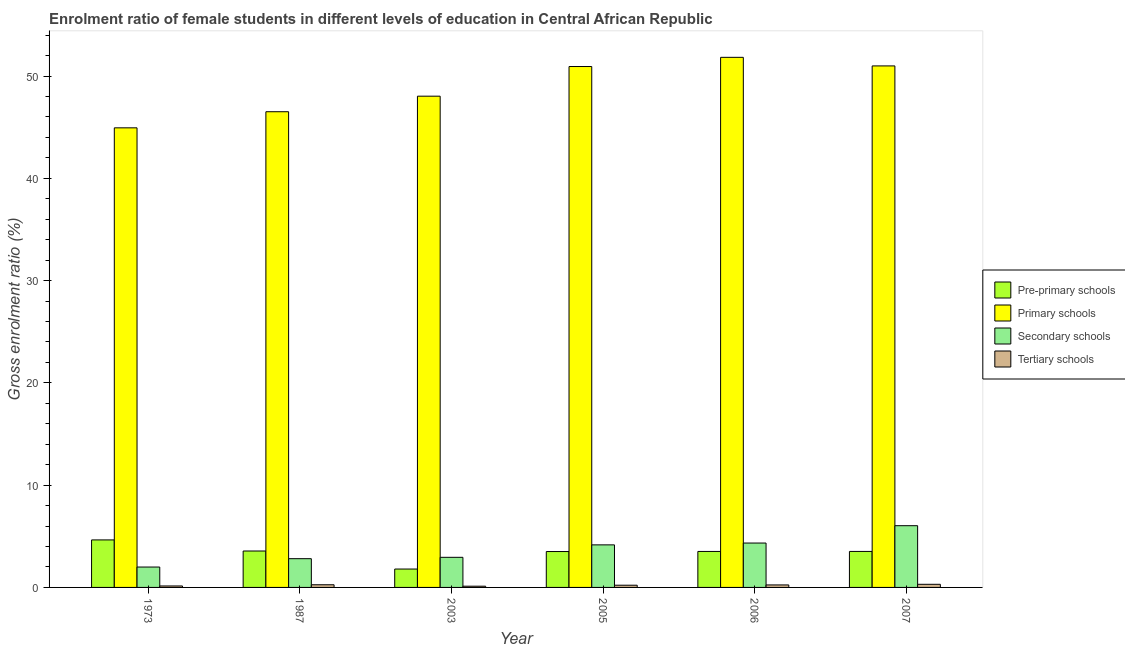How many bars are there on the 3rd tick from the right?
Your answer should be compact. 4. What is the label of the 2nd group of bars from the left?
Give a very brief answer. 1987. What is the gross enrolment ratio(male) in tertiary schools in 2007?
Provide a short and direct response. 0.31. Across all years, what is the maximum gross enrolment ratio(male) in tertiary schools?
Offer a terse response. 0.31. Across all years, what is the minimum gross enrolment ratio(male) in tertiary schools?
Offer a terse response. 0.12. What is the total gross enrolment ratio(male) in pre-primary schools in the graph?
Provide a succinct answer. 20.55. What is the difference between the gross enrolment ratio(male) in tertiary schools in 1973 and that in 2006?
Your answer should be very brief. -0.1. What is the difference between the gross enrolment ratio(male) in tertiary schools in 2007 and the gross enrolment ratio(male) in secondary schools in 1973?
Offer a terse response. 0.16. What is the average gross enrolment ratio(male) in primary schools per year?
Offer a terse response. 48.88. In the year 2007, what is the difference between the gross enrolment ratio(male) in secondary schools and gross enrolment ratio(male) in primary schools?
Your response must be concise. 0. What is the ratio of the gross enrolment ratio(male) in primary schools in 1973 to that in 2003?
Your answer should be compact. 0.94. What is the difference between the highest and the second highest gross enrolment ratio(male) in pre-primary schools?
Your response must be concise. 1.08. What is the difference between the highest and the lowest gross enrolment ratio(male) in secondary schools?
Make the answer very short. 4.04. In how many years, is the gross enrolment ratio(male) in primary schools greater than the average gross enrolment ratio(male) in primary schools taken over all years?
Ensure brevity in your answer.  3. Is the sum of the gross enrolment ratio(male) in secondary schools in 1987 and 2006 greater than the maximum gross enrolment ratio(male) in pre-primary schools across all years?
Ensure brevity in your answer.  Yes. Is it the case that in every year, the sum of the gross enrolment ratio(male) in pre-primary schools and gross enrolment ratio(male) in secondary schools is greater than the sum of gross enrolment ratio(male) in primary schools and gross enrolment ratio(male) in tertiary schools?
Offer a terse response. Yes. What does the 1st bar from the left in 1987 represents?
Your response must be concise. Pre-primary schools. What does the 1st bar from the right in 2007 represents?
Provide a short and direct response. Tertiary schools. Is it the case that in every year, the sum of the gross enrolment ratio(male) in pre-primary schools and gross enrolment ratio(male) in primary schools is greater than the gross enrolment ratio(male) in secondary schools?
Your response must be concise. Yes. Are all the bars in the graph horizontal?
Offer a very short reply. No. How many years are there in the graph?
Your response must be concise. 6. Does the graph contain any zero values?
Offer a very short reply. No. Does the graph contain grids?
Keep it short and to the point. No. Where does the legend appear in the graph?
Your response must be concise. Center right. How many legend labels are there?
Offer a very short reply. 4. What is the title of the graph?
Give a very brief answer. Enrolment ratio of female students in different levels of education in Central African Republic. What is the Gross enrolment ratio (%) of Pre-primary schools in 1973?
Offer a very short reply. 4.65. What is the Gross enrolment ratio (%) of Primary schools in 1973?
Your response must be concise. 44.94. What is the Gross enrolment ratio (%) of Secondary schools in 1973?
Make the answer very short. 1.99. What is the Gross enrolment ratio (%) in Tertiary schools in 1973?
Your response must be concise. 0.14. What is the Gross enrolment ratio (%) of Pre-primary schools in 1987?
Your answer should be compact. 3.56. What is the Gross enrolment ratio (%) in Primary schools in 1987?
Offer a very short reply. 46.51. What is the Gross enrolment ratio (%) in Secondary schools in 1987?
Your answer should be compact. 2.81. What is the Gross enrolment ratio (%) in Tertiary schools in 1987?
Make the answer very short. 0.26. What is the Gross enrolment ratio (%) of Pre-primary schools in 2003?
Provide a short and direct response. 1.8. What is the Gross enrolment ratio (%) in Primary schools in 2003?
Provide a short and direct response. 48.03. What is the Gross enrolment ratio (%) of Secondary schools in 2003?
Your response must be concise. 2.94. What is the Gross enrolment ratio (%) of Tertiary schools in 2003?
Give a very brief answer. 0.12. What is the Gross enrolment ratio (%) in Pre-primary schools in 2005?
Keep it short and to the point. 3.51. What is the Gross enrolment ratio (%) in Primary schools in 2005?
Provide a short and direct response. 50.94. What is the Gross enrolment ratio (%) in Secondary schools in 2005?
Give a very brief answer. 4.16. What is the Gross enrolment ratio (%) of Tertiary schools in 2005?
Your answer should be compact. 0.22. What is the Gross enrolment ratio (%) in Pre-primary schools in 2006?
Your answer should be compact. 3.52. What is the Gross enrolment ratio (%) in Primary schools in 2006?
Your response must be concise. 51.83. What is the Gross enrolment ratio (%) in Secondary schools in 2006?
Your response must be concise. 4.34. What is the Gross enrolment ratio (%) in Tertiary schools in 2006?
Your answer should be compact. 0.24. What is the Gross enrolment ratio (%) in Pre-primary schools in 2007?
Offer a very short reply. 3.52. What is the Gross enrolment ratio (%) of Primary schools in 2007?
Ensure brevity in your answer.  50.99. What is the Gross enrolment ratio (%) of Secondary schools in 2007?
Ensure brevity in your answer.  6.04. What is the Gross enrolment ratio (%) in Tertiary schools in 2007?
Offer a terse response. 0.31. Across all years, what is the maximum Gross enrolment ratio (%) in Pre-primary schools?
Give a very brief answer. 4.65. Across all years, what is the maximum Gross enrolment ratio (%) of Primary schools?
Ensure brevity in your answer.  51.83. Across all years, what is the maximum Gross enrolment ratio (%) in Secondary schools?
Provide a succinct answer. 6.04. Across all years, what is the maximum Gross enrolment ratio (%) in Tertiary schools?
Your response must be concise. 0.31. Across all years, what is the minimum Gross enrolment ratio (%) of Pre-primary schools?
Your answer should be very brief. 1.8. Across all years, what is the minimum Gross enrolment ratio (%) in Primary schools?
Your answer should be compact. 44.94. Across all years, what is the minimum Gross enrolment ratio (%) in Secondary schools?
Make the answer very short. 1.99. Across all years, what is the minimum Gross enrolment ratio (%) in Tertiary schools?
Your answer should be very brief. 0.12. What is the total Gross enrolment ratio (%) of Pre-primary schools in the graph?
Your answer should be compact. 20.55. What is the total Gross enrolment ratio (%) in Primary schools in the graph?
Give a very brief answer. 293.25. What is the total Gross enrolment ratio (%) of Secondary schools in the graph?
Give a very brief answer. 22.29. What is the total Gross enrolment ratio (%) in Tertiary schools in the graph?
Give a very brief answer. 1.29. What is the difference between the Gross enrolment ratio (%) of Pre-primary schools in 1973 and that in 1987?
Provide a succinct answer. 1.08. What is the difference between the Gross enrolment ratio (%) in Primary schools in 1973 and that in 1987?
Keep it short and to the point. -1.57. What is the difference between the Gross enrolment ratio (%) of Secondary schools in 1973 and that in 1987?
Your answer should be very brief. -0.82. What is the difference between the Gross enrolment ratio (%) of Tertiary schools in 1973 and that in 1987?
Make the answer very short. -0.12. What is the difference between the Gross enrolment ratio (%) in Pre-primary schools in 1973 and that in 2003?
Your answer should be very brief. 2.85. What is the difference between the Gross enrolment ratio (%) of Primary schools in 1973 and that in 2003?
Your answer should be compact. -3.09. What is the difference between the Gross enrolment ratio (%) of Secondary schools in 1973 and that in 2003?
Offer a very short reply. -0.95. What is the difference between the Gross enrolment ratio (%) in Tertiary schools in 1973 and that in 2003?
Offer a very short reply. 0.02. What is the difference between the Gross enrolment ratio (%) of Pre-primary schools in 1973 and that in 2005?
Your answer should be very brief. 1.14. What is the difference between the Gross enrolment ratio (%) of Primary schools in 1973 and that in 2005?
Ensure brevity in your answer.  -6. What is the difference between the Gross enrolment ratio (%) of Secondary schools in 1973 and that in 2005?
Your answer should be very brief. -2.17. What is the difference between the Gross enrolment ratio (%) in Tertiary schools in 1973 and that in 2005?
Make the answer very short. -0.07. What is the difference between the Gross enrolment ratio (%) in Pre-primary schools in 1973 and that in 2006?
Your response must be concise. 1.13. What is the difference between the Gross enrolment ratio (%) of Primary schools in 1973 and that in 2006?
Keep it short and to the point. -6.89. What is the difference between the Gross enrolment ratio (%) of Secondary schools in 1973 and that in 2006?
Your answer should be compact. -2.35. What is the difference between the Gross enrolment ratio (%) in Tertiary schools in 1973 and that in 2006?
Your answer should be compact. -0.1. What is the difference between the Gross enrolment ratio (%) in Pre-primary schools in 1973 and that in 2007?
Keep it short and to the point. 1.13. What is the difference between the Gross enrolment ratio (%) in Primary schools in 1973 and that in 2007?
Make the answer very short. -6.05. What is the difference between the Gross enrolment ratio (%) of Secondary schools in 1973 and that in 2007?
Provide a short and direct response. -4.04. What is the difference between the Gross enrolment ratio (%) of Tertiary schools in 1973 and that in 2007?
Make the answer very short. -0.16. What is the difference between the Gross enrolment ratio (%) in Pre-primary schools in 1987 and that in 2003?
Provide a succinct answer. 1.76. What is the difference between the Gross enrolment ratio (%) of Primary schools in 1987 and that in 2003?
Give a very brief answer. -1.52. What is the difference between the Gross enrolment ratio (%) of Secondary schools in 1987 and that in 2003?
Your response must be concise. -0.13. What is the difference between the Gross enrolment ratio (%) in Tertiary schools in 1987 and that in 2003?
Keep it short and to the point. 0.14. What is the difference between the Gross enrolment ratio (%) in Pre-primary schools in 1987 and that in 2005?
Give a very brief answer. 0.05. What is the difference between the Gross enrolment ratio (%) in Primary schools in 1987 and that in 2005?
Your answer should be compact. -4.42. What is the difference between the Gross enrolment ratio (%) in Secondary schools in 1987 and that in 2005?
Your answer should be compact. -1.35. What is the difference between the Gross enrolment ratio (%) of Tertiary schools in 1987 and that in 2005?
Offer a terse response. 0.04. What is the difference between the Gross enrolment ratio (%) of Pre-primary schools in 1987 and that in 2006?
Provide a short and direct response. 0.04. What is the difference between the Gross enrolment ratio (%) of Primary schools in 1987 and that in 2006?
Offer a very short reply. -5.32. What is the difference between the Gross enrolment ratio (%) of Secondary schools in 1987 and that in 2006?
Keep it short and to the point. -1.53. What is the difference between the Gross enrolment ratio (%) in Tertiary schools in 1987 and that in 2006?
Provide a succinct answer. 0.02. What is the difference between the Gross enrolment ratio (%) of Pre-primary schools in 1987 and that in 2007?
Ensure brevity in your answer.  0.04. What is the difference between the Gross enrolment ratio (%) in Primary schools in 1987 and that in 2007?
Provide a succinct answer. -4.48. What is the difference between the Gross enrolment ratio (%) in Secondary schools in 1987 and that in 2007?
Keep it short and to the point. -3.22. What is the difference between the Gross enrolment ratio (%) in Tertiary schools in 1987 and that in 2007?
Provide a short and direct response. -0.04. What is the difference between the Gross enrolment ratio (%) in Pre-primary schools in 2003 and that in 2005?
Your answer should be compact. -1.71. What is the difference between the Gross enrolment ratio (%) of Primary schools in 2003 and that in 2005?
Provide a short and direct response. -2.9. What is the difference between the Gross enrolment ratio (%) of Secondary schools in 2003 and that in 2005?
Offer a very short reply. -1.22. What is the difference between the Gross enrolment ratio (%) in Tertiary schools in 2003 and that in 2005?
Your response must be concise. -0.1. What is the difference between the Gross enrolment ratio (%) in Pre-primary schools in 2003 and that in 2006?
Make the answer very short. -1.72. What is the difference between the Gross enrolment ratio (%) in Primary schools in 2003 and that in 2006?
Your answer should be very brief. -3.8. What is the difference between the Gross enrolment ratio (%) of Secondary schools in 2003 and that in 2006?
Provide a succinct answer. -1.4. What is the difference between the Gross enrolment ratio (%) of Tertiary schools in 2003 and that in 2006?
Your response must be concise. -0.12. What is the difference between the Gross enrolment ratio (%) in Pre-primary schools in 2003 and that in 2007?
Your answer should be compact. -1.72. What is the difference between the Gross enrolment ratio (%) of Primary schools in 2003 and that in 2007?
Keep it short and to the point. -2.96. What is the difference between the Gross enrolment ratio (%) in Secondary schools in 2003 and that in 2007?
Make the answer very short. -3.09. What is the difference between the Gross enrolment ratio (%) in Tertiary schools in 2003 and that in 2007?
Offer a very short reply. -0.19. What is the difference between the Gross enrolment ratio (%) in Pre-primary schools in 2005 and that in 2006?
Offer a terse response. -0.01. What is the difference between the Gross enrolment ratio (%) in Primary schools in 2005 and that in 2006?
Keep it short and to the point. -0.9. What is the difference between the Gross enrolment ratio (%) of Secondary schools in 2005 and that in 2006?
Give a very brief answer. -0.18. What is the difference between the Gross enrolment ratio (%) in Tertiary schools in 2005 and that in 2006?
Make the answer very short. -0.03. What is the difference between the Gross enrolment ratio (%) of Pre-primary schools in 2005 and that in 2007?
Your answer should be compact. -0.01. What is the difference between the Gross enrolment ratio (%) in Primary schools in 2005 and that in 2007?
Make the answer very short. -0.06. What is the difference between the Gross enrolment ratio (%) of Secondary schools in 2005 and that in 2007?
Your answer should be very brief. -1.87. What is the difference between the Gross enrolment ratio (%) of Tertiary schools in 2005 and that in 2007?
Provide a short and direct response. -0.09. What is the difference between the Gross enrolment ratio (%) in Pre-primary schools in 2006 and that in 2007?
Make the answer very short. -0. What is the difference between the Gross enrolment ratio (%) in Primary schools in 2006 and that in 2007?
Make the answer very short. 0.84. What is the difference between the Gross enrolment ratio (%) in Secondary schools in 2006 and that in 2007?
Give a very brief answer. -1.69. What is the difference between the Gross enrolment ratio (%) in Tertiary schools in 2006 and that in 2007?
Ensure brevity in your answer.  -0.06. What is the difference between the Gross enrolment ratio (%) of Pre-primary schools in 1973 and the Gross enrolment ratio (%) of Primary schools in 1987?
Keep it short and to the point. -41.87. What is the difference between the Gross enrolment ratio (%) in Pre-primary schools in 1973 and the Gross enrolment ratio (%) in Secondary schools in 1987?
Your response must be concise. 1.83. What is the difference between the Gross enrolment ratio (%) in Pre-primary schools in 1973 and the Gross enrolment ratio (%) in Tertiary schools in 1987?
Keep it short and to the point. 4.38. What is the difference between the Gross enrolment ratio (%) in Primary schools in 1973 and the Gross enrolment ratio (%) in Secondary schools in 1987?
Give a very brief answer. 42.13. What is the difference between the Gross enrolment ratio (%) of Primary schools in 1973 and the Gross enrolment ratio (%) of Tertiary schools in 1987?
Ensure brevity in your answer.  44.68. What is the difference between the Gross enrolment ratio (%) in Secondary schools in 1973 and the Gross enrolment ratio (%) in Tertiary schools in 1987?
Provide a succinct answer. 1.73. What is the difference between the Gross enrolment ratio (%) in Pre-primary schools in 1973 and the Gross enrolment ratio (%) in Primary schools in 2003?
Your answer should be very brief. -43.39. What is the difference between the Gross enrolment ratio (%) of Pre-primary schools in 1973 and the Gross enrolment ratio (%) of Secondary schools in 2003?
Keep it short and to the point. 1.7. What is the difference between the Gross enrolment ratio (%) of Pre-primary schools in 1973 and the Gross enrolment ratio (%) of Tertiary schools in 2003?
Offer a very short reply. 4.53. What is the difference between the Gross enrolment ratio (%) of Primary schools in 1973 and the Gross enrolment ratio (%) of Secondary schools in 2003?
Keep it short and to the point. 42. What is the difference between the Gross enrolment ratio (%) of Primary schools in 1973 and the Gross enrolment ratio (%) of Tertiary schools in 2003?
Ensure brevity in your answer.  44.82. What is the difference between the Gross enrolment ratio (%) of Secondary schools in 1973 and the Gross enrolment ratio (%) of Tertiary schools in 2003?
Your response must be concise. 1.87. What is the difference between the Gross enrolment ratio (%) in Pre-primary schools in 1973 and the Gross enrolment ratio (%) in Primary schools in 2005?
Your response must be concise. -46.29. What is the difference between the Gross enrolment ratio (%) in Pre-primary schools in 1973 and the Gross enrolment ratio (%) in Secondary schools in 2005?
Give a very brief answer. 0.48. What is the difference between the Gross enrolment ratio (%) of Pre-primary schools in 1973 and the Gross enrolment ratio (%) of Tertiary schools in 2005?
Offer a terse response. 4.43. What is the difference between the Gross enrolment ratio (%) of Primary schools in 1973 and the Gross enrolment ratio (%) of Secondary schools in 2005?
Make the answer very short. 40.78. What is the difference between the Gross enrolment ratio (%) of Primary schools in 1973 and the Gross enrolment ratio (%) of Tertiary schools in 2005?
Make the answer very short. 44.72. What is the difference between the Gross enrolment ratio (%) of Secondary schools in 1973 and the Gross enrolment ratio (%) of Tertiary schools in 2005?
Give a very brief answer. 1.78. What is the difference between the Gross enrolment ratio (%) of Pre-primary schools in 1973 and the Gross enrolment ratio (%) of Primary schools in 2006?
Provide a short and direct response. -47.19. What is the difference between the Gross enrolment ratio (%) of Pre-primary schools in 1973 and the Gross enrolment ratio (%) of Secondary schools in 2006?
Provide a succinct answer. 0.31. What is the difference between the Gross enrolment ratio (%) in Pre-primary schools in 1973 and the Gross enrolment ratio (%) in Tertiary schools in 2006?
Your answer should be very brief. 4.4. What is the difference between the Gross enrolment ratio (%) in Primary schools in 1973 and the Gross enrolment ratio (%) in Secondary schools in 2006?
Keep it short and to the point. 40.6. What is the difference between the Gross enrolment ratio (%) in Primary schools in 1973 and the Gross enrolment ratio (%) in Tertiary schools in 2006?
Keep it short and to the point. 44.7. What is the difference between the Gross enrolment ratio (%) in Secondary schools in 1973 and the Gross enrolment ratio (%) in Tertiary schools in 2006?
Offer a terse response. 1.75. What is the difference between the Gross enrolment ratio (%) in Pre-primary schools in 1973 and the Gross enrolment ratio (%) in Primary schools in 2007?
Offer a terse response. -46.35. What is the difference between the Gross enrolment ratio (%) of Pre-primary schools in 1973 and the Gross enrolment ratio (%) of Secondary schools in 2007?
Offer a terse response. -1.39. What is the difference between the Gross enrolment ratio (%) of Pre-primary schools in 1973 and the Gross enrolment ratio (%) of Tertiary schools in 2007?
Provide a short and direct response. 4.34. What is the difference between the Gross enrolment ratio (%) of Primary schools in 1973 and the Gross enrolment ratio (%) of Secondary schools in 2007?
Ensure brevity in your answer.  38.9. What is the difference between the Gross enrolment ratio (%) of Primary schools in 1973 and the Gross enrolment ratio (%) of Tertiary schools in 2007?
Your answer should be compact. 44.63. What is the difference between the Gross enrolment ratio (%) in Secondary schools in 1973 and the Gross enrolment ratio (%) in Tertiary schools in 2007?
Offer a terse response. 1.69. What is the difference between the Gross enrolment ratio (%) of Pre-primary schools in 1987 and the Gross enrolment ratio (%) of Primary schools in 2003?
Give a very brief answer. -44.47. What is the difference between the Gross enrolment ratio (%) in Pre-primary schools in 1987 and the Gross enrolment ratio (%) in Secondary schools in 2003?
Your response must be concise. 0.62. What is the difference between the Gross enrolment ratio (%) in Pre-primary schools in 1987 and the Gross enrolment ratio (%) in Tertiary schools in 2003?
Your answer should be very brief. 3.44. What is the difference between the Gross enrolment ratio (%) in Primary schools in 1987 and the Gross enrolment ratio (%) in Secondary schools in 2003?
Ensure brevity in your answer.  43.57. What is the difference between the Gross enrolment ratio (%) in Primary schools in 1987 and the Gross enrolment ratio (%) in Tertiary schools in 2003?
Offer a very short reply. 46.39. What is the difference between the Gross enrolment ratio (%) in Secondary schools in 1987 and the Gross enrolment ratio (%) in Tertiary schools in 2003?
Provide a succinct answer. 2.69. What is the difference between the Gross enrolment ratio (%) in Pre-primary schools in 1987 and the Gross enrolment ratio (%) in Primary schools in 2005?
Offer a very short reply. -47.37. What is the difference between the Gross enrolment ratio (%) of Pre-primary schools in 1987 and the Gross enrolment ratio (%) of Secondary schools in 2005?
Ensure brevity in your answer.  -0.6. What is the difference between the Gross enrolment ratio (%) in Pre-primary schools in 1987 and the Gross enrolment ratio (%) in Tertiary schools in 2005?
Offer a terse response. 3.34. What is the difference between the Gross enrolment ratio (%) of Primary schools in 1987 and the Gross enrolment ratio (%) of Secondary schools in 2005?
Your answer should be compact. 42.35. What is the difference between the Gross enrolment ratio (%) in Primary schools in 1987 and the Gross enrolment ratio (%) in Tertiary schools in 2005?
Keep it short and to the point. 46.3. What is the difference between the Gross enrolment ratio (%) in Secondary schools in 1987 and the Gross enrolment ratio (%) in Tertiary schools in 2005?
Keep it short and to the point. 2.59. What is the difference between the Gross enrolment ratio (%) in Pre-primary schools in 1987 and the Gross enrolment ratio (%) in Primary schools in 2006?
Offer a very short reply. -48.27. What is the difference between the Gross enrolment ratio (%) of Pre-primary schools in 1987 and the Gross enrolment ratio (%) of Secondary schools in 2006?
Provide a succinct answer. -0.78. What is the difference between the Gross enrolment ratio (%) in Pre-primary schools in 1987 and the Gross enrolment ratio (%) in Tertiary schools in 2006?
Your answer should be compact. 3.32. What is the difference between the Gross enrolment ratio (%) in Primary schools in 1987 and the Gross enrolment ratio (%) in Secondary schools in 2006?
Ensure brevity in your answer.  42.17. What is the difference between the Gross enrolment ratio (%) in Primary schools in 1987 and the Gross enrolment ratio (%) in Tertiary schools in 2006?
Provide a succinct answer. 46.27. What is the difference between the Gross enrolment ratio (%) of Secondary schools in 1987 and the Gross enrolment ratio (%) of Tertiary schools in 2006?
Your answer should be very brief. 2.57. What is the difference between the Gross enrolment ratio (%) in Pre-primary schools in 1987 and the Gross enrolment ratio (%) in Primary schools in 2007?
Make the answer very short. -47.43. What is the difference between the Gross enrolment ratio (%) in Pre-primary schools in 1987 and the Gross enrolment ratio (%) in Secondary schools in 2007?
Offer a terse response. -2.47. What is the difference between the Gross enrolment ratio (%) in Pre-primary schools in 1987 and the Gross enrolment ratio (%) in Tertiary schools in 2007?
Give a very brief answer. 3.26. What is the difference between the Gross enrolment ratio (%) in Primary schools in 1987 and the Gross enrolment ratio (%) in Secondary schools in 2007?
Give a very brief answer. 40.48. What is the difference between the Gross enrolment ratio (%) of Primary schools in 1987 and the Gross enrolment ratio (%) of Tertiary schools in 2007?
Your answer should be compact. 46.21. What is the difference between the Gross enrolment ratio (%) in Secondary schools in 1987 and the Gross enrolment ratio (%) in Tertiary schools in 2007?
Your answer should be compact. 2.51. What is the difference between the Gross enrolment ratio (%) of Pre-primary schools in 2003 and the Gross enrolment ratio (%) of Primary schools in 2005?
Give a very brief answer. -49.14. What is the difference between the Gross enrolment ratio (%) in Pre-primary schools in 2003 and the Gross enrolment ratio (%) in Secondary schools in 2005?
Offer a terse response. -2.36. What is the difference between the Gross enrolment ratio (%) of Pre-primary schools in 2003 and the Gross enrolment ratio (%) of Tertiary schools in 2005?
Your answer should be compact. 1.58. What is the difference between the Gross enrolment ratio (%) in Primary schools in 2003 and the Gross enrolment ratio (%) in Secondary schools in 2005?
Keep it short and to the point. 43.87. What is the difference between the Gross enrolment ratio (%) of Primary schools in 2003 and the Gross enrolment ratio (%) of Tertiary schools in 2005?
Provide a short and direct response. 47.82. What is the difference between the Gross enrolment ratio (%) in Secondary schools in 2003 and the Gross enrolment ratio (%) in Tertiary schools in 2005?
Your response must be concise. 2.73. What is the difference between the Gross enrolment ratio (%) of Pre-primary schools in 2003 and the Gross enrolment ratio (%) of Primary schools in 2006?
Offer a terse response. -50.04. What is the difference between the Gross enrolment ratio (%) in Pre-primary schools in 2003 and the Gross enrolment ratio (%) in Secondary schools in 2006?
Your answer should be compact. -2.54. What is the difference between the Gross enrolment ratio (%) of Pre-primary schools in 2003 and the Gross enrolment ratio (%) of Tertiary schools in 2006?
Ensure brevity in your answer.  1.55. What is the difference between the Gross enrolment ratio (%) in Primary schools in 2003 and the Gross enrolment ratio (%) in Secondary schools in 2006?
Offer a very short reply. 43.69. What is the difference between the Gross enrolment ratio (%) of Primary schools in 2003 and the Gross enrolment ratio (%) of Tertiary schools in 2006?
Provide a short and direct response. 47.79. What is the difference between the Gross enrolment ratio (%) in Secondary schools in 2003 and the Gross enrolment ratio (%) in Tertiary schools in 2006?
Keep it short and to the point. 2.7. What is the difference between the Gross enrolment ratio (%) in Pre-primary schools in 2003 and the Gross enrolment ratio (%) in Primary schools in 2007?
Provide a succinct answer. -49.2. What is the difference between the Gross enrolment ratio (%) in Pre-primary schools in 2003 and the Gross enrolment ratio (%) in Secondary schools in 2007?
Offer a terse response. -4.24. What is the difference between the Gross enrolment ratio (%) of Pre-primary schools in 2003 and the Gross enrolment ratio (%) of Tertiary schools in 2007?
Your answer should be very brief. 1.49. What is the difference between the Gross enrolment ratio (%) in Primary schools in 2003 and the Gross enrolment ratio (%) in Secondary schools in 2007?
Make the answer very short. 42. What is the difference between the Gross enrolment ratio (%) of Primary schools in 2003 and the Gross enrolment ratio (%) of Tertiary schools in 2007?
Give a very brief answer. 47.73. What is the difference between the Gross enrolment ratio (%) of Secondary schools in 2003 and the Gross enrolment ratio (%) of Tertiary schools in 2007?
Your answer should be compact. 2.64. What is the difference between the Gross enrolment ratio (%) in Pre-primary schools in 2005 and the Gross enrolment ratio (%) in Primary schools in 2006?
Your response must be concise. -48.33. What is the difference between the Gross enrolment ratio (%) of Pre-primary schools in 2005 and the Gross enrolment ratio (%) of Secondary schools in 2006?
Ensure brevity in your answer.  -0.83. What is the difference between the Gross enrolment ratio (%) of Pre-primary schools in 2005 and the Gross enrolment ratio (%) of Tertiary schools in 2006?
Keep it short and to the point. 3.26. What is the difference between the Gross enrolment ratio (%) of Primary schools in 2005 and the Gross enrolment ratio (%) of Secondary schools in 2006?
Give a very brief answer. 46.59. What is the difference between the Gross enrolment ratio (%) in Primary schools in 2005 and the Gross enrolment ratio (%) in Tertiary schools in 2006?
Your answer should be very brief. 50.69. What is the difference between the Gross enrolment ratio (%) of Secondary schools in 2005 and the Gross enrolment ratio (%) of Tertiary schools in 2006?
Give a very brief answer. 3.92. What is the difference between the Gross enrolment ratio (%) of Pre-primary schools in 2005 and the Gross enrolment ratio (%) of Primary schools in 2007?
Your answer should be very brief. -47.48. What is the difference between the Gross enrolment ratio (%) in Pre-primary schools in 2005 and the Gross enrolment ratio (%) in Secondary schools in 2007?
Your response must be concise. -2.53. What is the difference between the Gross enrolment ratio (%) in Pre-primary schools in 2005 and the Gross enrolment ratio (%) in Tertiary schools in 2007?
Keep it short and to the point. 3.2. What is the difference between the Gross enrolment ratio (%) of Primary schools in 2005 and the Gross enrolment ratio (%) of Secondary schools in 2007?
Offer a very short reply. 44.9. What is the difference between the Gross enrolment ratio (%) of Primary schools in 2005 and the Gross enrolment ratio (%) of Tertiary schools in 2007?
Offer a terse response. 50.63. What is the difference between the Gross enrolment ratio (%) of Secondary schools in 2005 and the Gross enrolment ratio (%) of Tertiary schools in 2007?
Your answer should be very brief. 3.86. What is the difference between the Gross enrolment ratio (%) of Pre-primary schools in 2006 and the Gross enrolment ratio (%) of Primary schools in 2007?
Your answer should be very brief. -47.47. What is the difference between the Gross enrolment ratio (%) of Pre-primary schools in 2006 and the Gross enrolment ratio (%) of Secondary schools in 2007?
Provide a short and direct response. -2.52. What is the difference between the Gross enrolment ratio (%) in Pre-primary schools in 2006 and the Gross enrolment ratio (%) in Tertiary schools in 2007?
Offer a very short reply. 3.21. What is the difference between the Gross enrolment ratio (%) in Primary schools in 2006 and the Gross enrolment ratio (%) in Secondary schools in 2007?
Keep it short and to the point. 45.8. What is the difference between the Gross enrolment ratio (%) of Primary schools in 2006 and the Gross enrolment ratio (%) of Tertiary schools in 2007?
Give a very brief answer. 51.53. What is the difference between the Gross enrolment ratio (%) of Secondary schools in 2006 and the Gross enrolment ratio (%) of Tertiary schools in 2007?
Your response must be concise. 4.04. What is the average Gross enrolment ratio (%) in Pre-primary schools per year?
Keep it short and to the point. 3.43. What is the average Gross enrolment ratio (%) of Primary schools per year?
Provide a succinct answer. 48.88. What is the average Gross enrolment ratio (%) in Secondary schools per year?
Your answer should be compact. 3.71. What is the average Gross enrolment ratio (%) in Tertiary schools per year?
Offer a very short reply. 0.22. In the year 1973, what is the difference between the Gross enrolment ratio (%) of Pre-primary schools and Gross enrolment ratio (%) of Primary schools?
Your answer should be compact. -40.29. In the year 1973, what is the difference between the Gross enrolment ratio (%) of Pre-primary schools and Gross enrolment ratio (%) of Secondary schools?
Your response must be concise. 2.65. In the year 1973, what is the difference between the Gross enrolment ratio (%) of Pre-primary schools and Gross enrolment ratio (%) of Tertiary schools?
Your answer should be compact. 4.5. In the year 1973, what is the difference between the Gross enrolment ratio (%) of Primary schools and Gross enrolment ratio (%) of Secondary schools?
Keep it short and to the point. 42.95. In the year 1973, what is the difference between the Gross enrolment ratio (%) in Primary schools and Gross enrolment ratio (%) in Tertiary schools?
Provide a succinct answer. 44.8. In the year 1973, what is the difference between the Gross enrolment ratio (%) in Secondary schools and Gross enrolment ratio (%) in Tertiary schools?
Offer a very short reply. 1.85. In the year 1987, what is the difference between the Gross enrolment ratio (%) of Pre-primary schools and Gross enrolment ratio (%) of Primary schools?
Ensure brevity in your answer.  -42.95. In the year 1987, what is the difference between the Gross enrolment ratio (%) of Pre-primary schools and Gross enrolment ratio (%) of Secondary schools?
Provide a short and direct response. 0.75. In the year 1987, what is the difference between the Gross enrolment ratio (%) of Pre-primary schools and Gross enrolment ratio (%) of Tertiary schools?
Offer a very short reply. 3.3. In the year 1987, what is the difference between the Gross enrolment ratio (%) of Primary schools and Gross enrolment ratio (%) of Secondary schools?
Offer a very short reply. 43.7. In the year 1987, what is the difference between the Gross enrolment ratio (%) in Primary schools and Gross enrolment ratio (%) in Tertiary schools?
Your response must be concise. 46.25. In the year 1987, what is the difference between the Gross enrolment ratio (%) of Secondary schools and Gross enrolment ratio (%) of Tertiary schools?
Keep it short and to the point. 2.55. In the year 2003, what is the difference between the Gross enrolment ratio (%) of Pre-primary schools and Gross enrolment ratio (%) of Primary schools?
Your response must be concise. -46.24. In the year 2003, what is the difference between the Gross enrolment ratio (%) of Pre-primary schools and Gross enrolment ratio (%) of Secondary schools?
Offer a terse response. -1.15. In the year 2003, what is the difference between the Gross enrolment ratio (%) in Pre-primary schools and Gross enrolment ratio (%) in Tertiary schools?
Keep it short and to the point. 1.68. In the year 2003, what is the difference between the Gross enrolment ratio (%) of Primary schools and Gross enrolment ratio (%) of Secondary schools?
Make the answer very short. 45.09. In the year 2003, what is the difference between the Gross enrolment ratio (%) in Primary schools and Gross enrolment ratio (%) in Tertiary schools?
Offer a terse response. 47.91. In the year 2003, what is the difference between the Gross enrolment ratio (%) in Secondary schools and Gross enrolment ratio (%) in Tertiary schools?
Provide a short and direct response. 2.82. In the year 2005, what is the difference between the Gross enrolment ratio (%) of Pre-primary schools and Gross enrolment ratio (%) of Primary schools?
Offer a very short reply. -47.43. In the year 2005, what is the difference between the Gross enrolment ratio (%) in Pre-primary schools and Gross enrolment ratio (%) in Secondary schools?
Provide a succinct answer. -0.65. In the year 2005, what is the difference between the Gross enrolment ratio (%) in Pre-primary schools and Gross enrolment ratio (%) in Tertiary schools?
Provide a short and direct response. 3.29. In the year 2005, what is the difference between the Gross enrolment ratio (%) of Primary schools and Gross enrolment ratio (%) of Secondary schools?
Give a very brief answer. 46.77. In the year 2005, what is the difference between the Gross enrolment ratio (%) of Primary schools and Gross enrolment ratio (%) of Tertiary schools?
Offer a terse response. 50.72. In the year 2005, what is the difference between the Gross enrolment ratio (%) of Secondary schools and Gross enrolment ratio (%) of Tertiary schools?
Your response must be concise. 3.94. In the year 2006, what is the difference between the Gross enrolment ratio (%) of Pre-primary schools and Gross enrolment ratio (%) of Primary schools?
Offer a terse response. -48.31. In the year 2006, what is the difference between the Gross enrolment ratio (%) of Pre-primary schools and Gross enrolment ratio (%) of Secondary schools?
Your response must be concise. -0.82. In the year 2006, what is the difference between the Gross enrolment ratio (%) in Pre-primary schools and Gross enrolment ratio (%) in Tertiary schools?
Your response must be concise. 3.27. In the year 2006, what is the difference between the Gross enrolment ratio (%) of Primary schools and Gross enrolment ratio (%) of Secondary schools?
Your answer should be very brief. 47.49. In the year 2006, what is the difference between the Gross enrolment ratio (%) of Primary schools and Gross enrolment ratio (%) of Tertiary schools?
Keep it short and to the point. 51.59. In the year 2006, what is the difference between the Gross enrolment ratio (%) of Secondary schools and Gross enrolment ratio (%) of Tertiary schools?
Ensure brevity in your answer.  4.1. In the year 2007, what is the difference between the Gross enrolment ratio (%) of Pre-primary schools and Gross enrolment ratio (%) of Primary schools?
Give a very brief answer. -47.47. In the year 2007, what is the difference between the Gross enrolment ratio (%) of Pre-primary schools and Gross enrolment ratio (%) of Secondary schools?
Offer a terse response. -2.52. In the year 2007, what is the difference between the Gross enrolment ratio (%) in Pre-primary schools and Gross enrolment ratio (%) in Tertiary schools?
Give a very brief answer. 3.21. In the year 2007, what is the difference between the Gross enrolment ratio (%) of Primary schools and Gross enrolment ratio (%) of Secondary schools?
Provide a short and direct response. 44.96. In the year 2007, what is the difference between the Gross enrolment ratio (%) of Primary schools and Gross enrolment ratio (%) of Tertiary schools?
Your answer should be very brief. 50.69. In the year 2007, what is the difference between the Gross enrolment ratio (%) of Secondary schools and Gross enrolment ratio (%) of Tertiary schools?
Give a very brief answer. 5.73. What is the ratio of the Gross enrolment ratio (%) of Pre-primary schools in 1973 to that in 1987?
Offer a very short reply. 1.3. What is the ratio of the Gross enrolment ratio (%) in Primary schools in 1973 to that in 1987?
Offer a very short reply. 0.97. What is the ratio of the Gross enrolment ratio (%) of Secondary schools in 1973 to that in 1987?
Give a very brief answer. 0.71. What is the ratio of the Gross enrolment ratio (%) of Tertiary schools in 1973 to that in 1987?
Ensure brevity in your answer.  0.55. What is the ratio of the Gross enrolment ratio (%) of Pre-primary schools in 1973 to that in 2003?
Give a very brief answer. 2.58. What is the ratio of the Gross enrolment ratio (%) in Primary schools in 1973 to that in 2003?
Give a very brief answer. 0.94. What is the ratio of the Gross enrolment ratio (%) of Secondary schools in 1973 to that in 2003?
Give a very brief answer. 0.68. What is the ratio of the Gross enrolment ratio (%) in Tertiary schools in 1973 to that in 2003?
Make the answer very short. 1.2. What is the ratio of the Gross enrolment ratio (%) of Pre-primary schools in 1973 to that in 2005?
Offer a very short reply. 1.32. What is the ratio of the Gross enrolment ratio (%) of Primary schools in 1973 to that in 2005?
Provide a short and direct response. 0.88. What is the ratio of the Gross enrolment ratio (%) of Secondary schools in 1973 to that in 2005?
Offer a very short reply. 0.48. What is the ratio of the Gross enrolment ratio (%) of Tertiary schools in 1973 to that in 2005?
Make the answer very short. 0.66. What is the ratio of the Gross enrolment ratio (%) of Pre-primary schools in 1973 to that in 2006?
Your answer should be very brief. 1.32. What is the ratio of the Gross enrolment ratio (%) in Primary schools in 1973 to that in 2006?
Offer a very short reply. 0.87. What is the ratio of the Gross enrolment ratio (%) in Secondary schools in 1973 to that in 2006?
Offer a very short reply. 0.46. What is the ratio of the Gross enrolment ratio (%) of Tertiary schools in 1973 to that in 2006?
Keep it short and to the point. 0.59. What is the ratio of the Gross enrolment ratio (%) of Pre-primary schools in 1973 to that in 2007?
Keep it short and to the point. 1.32. What is the ratio of the Gross enrolment ratio (%) of Primary schools in 1973 to that in 2007?
Make the answer very short. 0.88. What is the ratio of the Gross enrolment ratio (%) in Secondary schools in 1973 to that in 2007?
Ensure brevity in your answer.  0.33. What is the ratio of the Gross enrolment ratio (%) of Tertiary schools in 1973 to that in 2007?
Your response must be concise. 0.47. What is the ratio of the Gross enrolment ratio (%) of Pre-primary schools in 1987 to that in 2003?
Give a very brief answer. 1.98. What is the ratio of the Gross enrolment ratio (%) of Primary schools in 1987 to that in 2003?
Keep it short and to the point. 0.97. What is the ratio of the Gross enrolment ratio (%) of Secondary schools in 1987 to that in 2003?
Your response must be concise. 0.95. What is the ratio of the Gross enrolment ratio (%) in Tertiary schools in 1987 to that in 2003?
Provide a succinct answer. 2.18. What is the ratio of the Gross enrolment ratio (%) of Pre-primary schools in 1987 to that in 2005?
Your response must be concise. 1.02. What is the ratio of the Gross enrolment ratio (%) in Primary schools in 1987 to that in 2005?
Provide a short and direct response. 0.91. What is the ratio of the Gross enrolment ratio (%) in Secondary schools in 1987 to that in 2005?
Make the answer very short. 0.68. What is the ratio of the Gross enrolment ratio (%) in Tertiary schools in 1987 to that in 2005?
Provide a succinct answer. 1.2. What is the ratio of the Gross enrolment ratio (%) of Pre-primary schools in 1987 to that in 2006?
Provide a short and direct response. 1.01. What is the ratio of the Gross enrolment ratio (%) in Primary schools in 1987 to that in 2006?
Keep it short and to the point. 0.9. What is the ratio of the Gross enrolment ratio (%) of Secondary schools in 1987 to that in 2006?
Offer a very short reply. 0.65. What is the ratio of the Gross enrolment ratio (%) in Tertiary schools in 1987 to that in 2006?
Make the answer very short. 1.07. What is the ratio of the Gross enrolment ratio (%) of Pre-primary schools in 1987 to that in 2007?
Your answer should be compact. 1.01. What is the ratio of the Gross enrolment ratio (%) in Primary schools in 1987 to that in 2007?
Provide a short and direct response. 0.91. What is the ratio of the Gross enrolment ratio (%) in Secondary schools in 1987 to that in 2007?
Ensure brevity in your answer.  0.47. What is the ratio of the Gross enrolment ratio (%) in Tertiary schools in 1987 to that in 2007?
Provide a succinct answer. 0.85. What is the ratio of the Gross enrolment ratio (%) of Pre-primary schools in 2003 to that in 2005?
Keep it short and to the point. 0.51. What is the ratio of the Gross enrolment ratio (%) of Primary schools in 2003 to that in 2005?
Make the answer very short. 0.94. What is the ratio of the Gross enrolment ratio (%) in Secondary schools in 2003 to that in 2005?
Keep it short and to the point. 0.71. What is the ratio of the Gross enrolment ratio (%) of Tertiary schools in 2003 to that in 2005?
Provide a short and direct response. 0.55. What is the ratio of the Gross enrolment ratio (%) of Pre-primary schools in 2003 to that in 2006?
Your response must be concise. 0.51. What is the ratio of the Gross enrolment ratio (%) of Primary schools in 2003 to that in 2006?
Offer a terse response. 0.93. What is the ratio of the Gross enrolment ratio (%) of Secondary schools in 2003 to that in 2006?
Ensure brevity in your answer.  0.68. What is the ratio of the Gross enrolment ratio (%) of Tertiary schools in 2003 to that in 2006?
Ensure brevity in your answer.  0.49. What is the ratio of the Gross enrolment ratio (%) of Pre-primary schools in 2003 to that in 2007?
Your answer should be very brief. 0.51. What is the ratio of the Gross enrolment ratio (%) of Primary schools in 2003 to that in 2007?
Make the answer very short. 0.94. What is the ratio of the Gross enrolment ratio (%) of Secondary schools in 2003 to that in 2007?
Your response must be concise. 0.49. What is the ratio of the Gross enrolment ratio (%) in Tertiary schools in 2003 to that in 2007?
Your answer should be very brief. 0.39. What is the ratio of the Gross enrolment ratio (%) of Pre-primary schools in 2005 to that in 2006?
Ensure brevity in your answer.  1. What is the ratio of the Gross enrolment ratio (%) in Primary schools in 2005 to that in 2006?
Offer a very short reply. 0.98. What is the ratio of the Gross enrolment ratio (%) in Secondary schools in 2005 to that in 2006?
Provide a short and direct response. 0.96. What is the ratio of the Gross enrolment ratio (%) of Tertiary schools in 2005 to that in 2006?
Your answer should be compact. 0.89. What is the ratio of the Gross enrolment ratio (%) of Secondary schools in 2005 to that in 2007?
Give a very brief answer. 0.69. What is the ratio of the Gross enrolment ratio (%) of Tertiary schools in 2005 to that in 2007?
Offer a terse response. 0.71. What is the ratio of the Gross enrolment ratio (%) in Pre-primary schools in 2006 to that in 2007?
Your answer should be very brief. 1. What is the ratio of the Gross enrolment ratio (%) in Primary schools in 2006 to that in 2007?
Provide a succinct answer. 1.02. What is the ratio of the Gross enrolment ratio (%) in Secondary schools in 2006 to that in 2007?
Offer a terse response. 0.72. What is the ratio of the Gross enrolment ratio (%) of Tertiary schools in 2006 to that in 2007?
Your answer should be very brief. 0.8. What is the difference between the highest and the second highest Gross enrolment ratio (%) in Pre-primary schools?
Make the answer very short. 1.08. What is the difference between the highest and the second highest Gross enrolment ratio (%) of Primary schools?
Provide a short and direct response. 0.84. What is the difference between the highest and the second highest Gross enrolment ratio (%) of Secondary schools?
Provide a succinct answer. 1.69. What is the difference between the highest and the second highest Gross enrolment ratio (%) of Tertiary schools?
Provide a succinct answer. 0.04. What is the difference between the highest and the lowest Gross enrolment ratio (%) of Pre-primary schools?
Offer a very short reply. 2.85. What is the difference between the highest and the lowest Gross enrolment ratio (%) of Primary schools?
Ensure brevity in your answer.  6.89. What is the difference between the highest and the lowest Gross enrolment ratio (%) in Secondary schools?
Offer a very short reply. 4.04. What is the difference between the highest and the lowest Gross enrolment ratio (%) in Tertiary schools?
Make the answer very short. 0.19. 